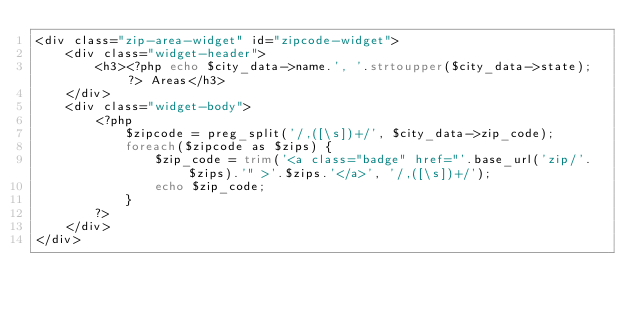<code> <loc_0><loc_0><loc_500><loc_500><_PHP_><div class="zip-area-widget" id="zipcode-widget">
	<div class="widget-header">
		<h3><?php echo $city_data->name.', '.strtoupper($city_data->state); ?> Areas</h3>
	</div>
	<div class="widget-body">
		<?php
			$zipcode = preg_split('/,([\s])+/', $city_data->zip_code);
			foreach($zipcode as $zips) {
				$zip_code = trim('<a class="badge" href="'.base_url('zip/'.$zips).'" >'.$zips.'</a>', '/,([\s])+/');
				echo $zip_code;
			}
		?>
	</div>
</div></code> 